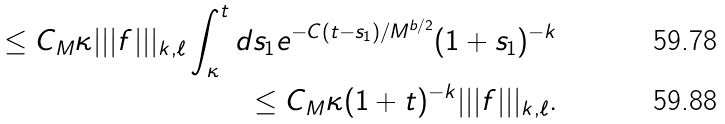<formula> <loc_0><loc_0><loc_500><loc_500>\leq C _ { M } \kappa | | | f | | | _ { k , \ell } \int _ { \kappa } ^ { t } d s _ { 1 } e ^ { - C ( t - s _ { 1 } ) / M ^ { b / 2 } } ( 1 + s _ { 1 } ) ^ { - k } \\ \leq C _ { M } \kappa ( 1 + t ) ^ { - k } | | | f | | | _ { k , \ell } .</formula> 